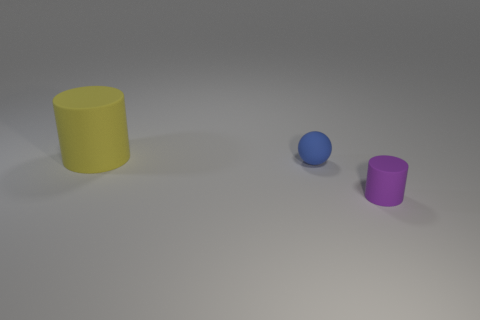Add 1 large green rubber cylinders. How many objects exist? 4 Subtract all spheres. How many objects are left? 2 Subtract all matte things. Subtract all small brown cylinders. How many objects are left? 0 Add 1 tiny rubber spheres. How many tiny rubber spheres are left? 2 Add 1 large matte objects. How many large matte objects exist? 2 Subtract 0 blue cubes. How many objects are left? 3 